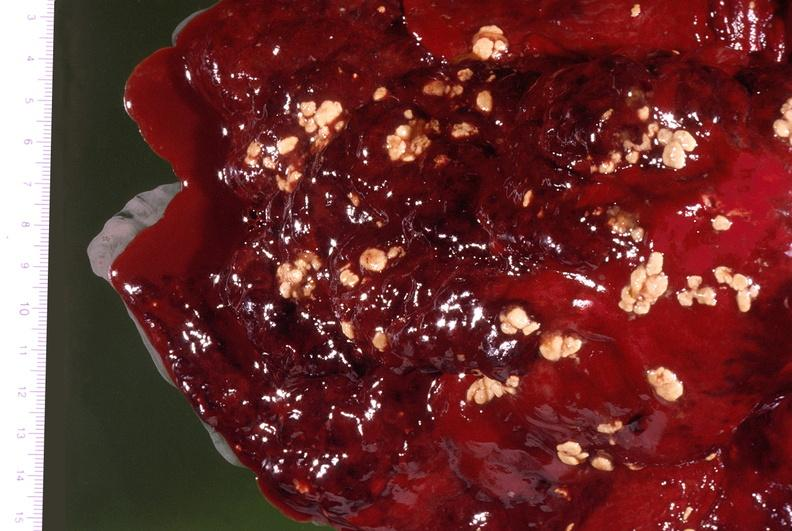does this image show pleural cavity, actinomyces sulfur granules?
Answer the question using a single word or phrase. Yes 